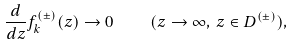Convert formula to latex. <formula><loc_0><loc_0><loc_500><loc_500>\frac { d } { d z } f _ { k } ^ { ( \pm ) } ( z ) \to 0 \quad ( z \to \infty , \, z \in D ^ { ( \pm ) } ) ,</formula> 